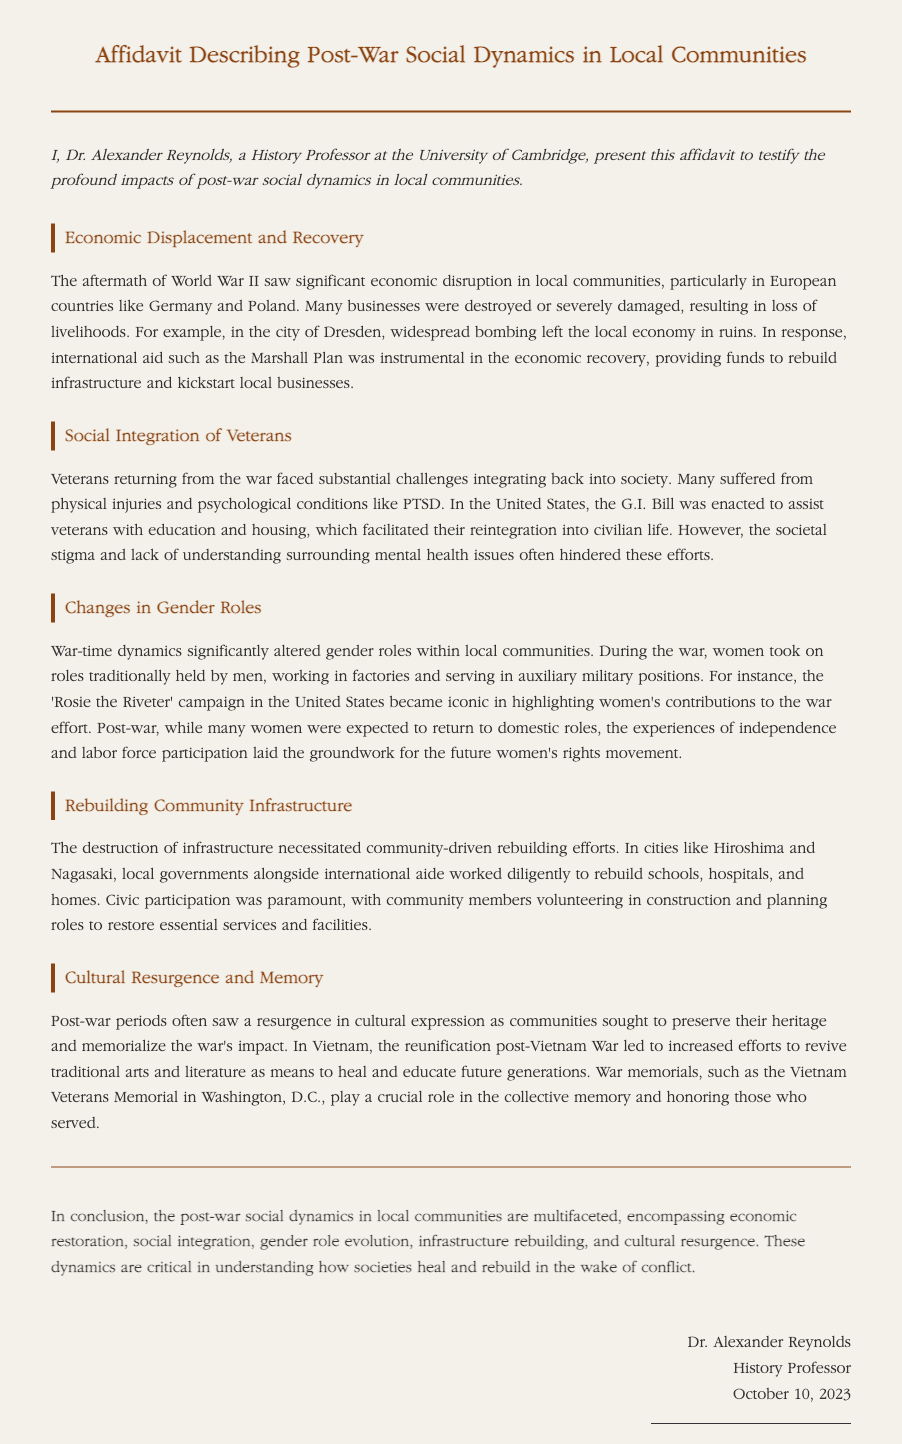What is the title of the document? The title of the document is explicitly mentioned at the top of the affidavit.
Answer: Affidavit Describing Post-War Social Dynamics in Local Communities Who authored the affidavit? The author's name is provided in the signature section of the document.
Answer: Dr. Alexander Reynolds What economic aid is mentioned as instrumental for recovery? The document specifies the type of international aid that assisted in economic recovery post-war.
Answer: Marshall Plan What major psychological condition did veterans face? The affidavit discusses a specific mental health challenge encountered by returning veterans.
Answer: PTSD What campaign highlighted women's contributions during the war? The document references a specific campaign related to women's roles during WWII.
Answer: Rosie the Riveter Which two cities were referenced in relation to rebuilding efforts? The affidavit identifies locations where community-driven rebuilding occurred post-war.
Answer: Hiroshima and Nagasaki What government initiative assisted U.S. veterans with education? The document mentions a specific bill aimed at helping veterans reintegrate into society.
Answer: G.I. Bill What is a crucial role of war memorials according to the document? The affidavit outlines the purpose of war memorials in relation to community memory and honoring service.
Answer: Collective memory What outcome resulted from changing gender roles as discussed? The affidavit indicates a long-term societal consequence of women's labor during the war.
Answer: Future women's rights movement 